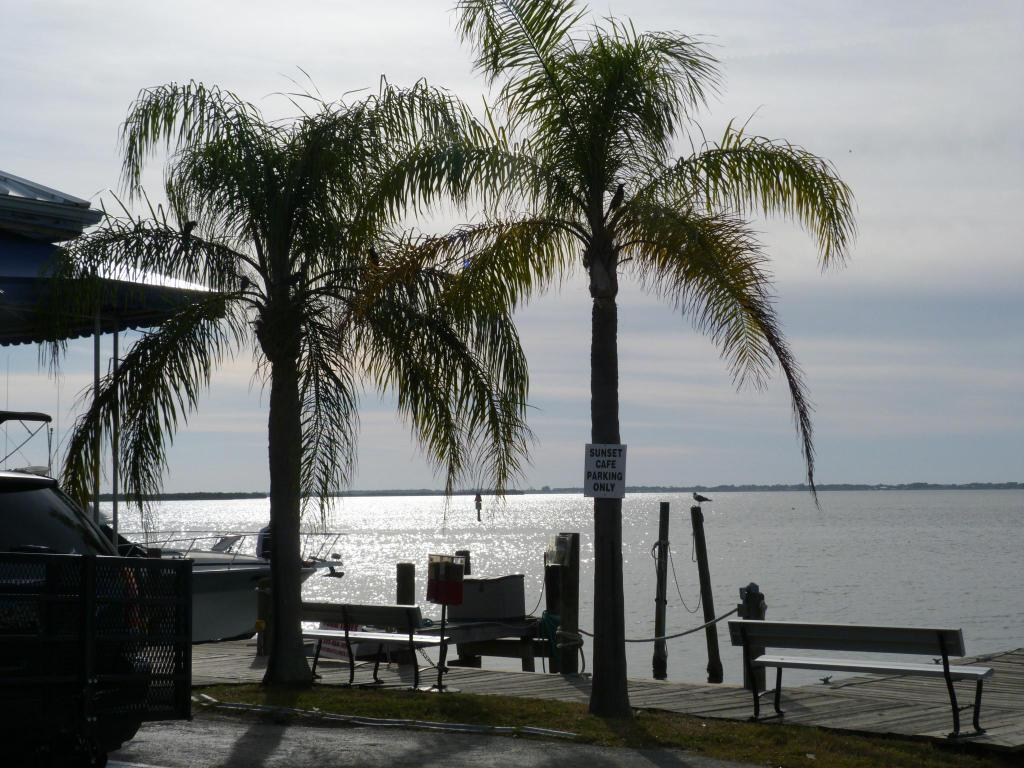What type of vegetation can be seen in the image? There are trees in the image. What is the main object in the water? There is a boat in the water in the image. What type of seating is available in the image? There are benches in the image. What is visible at the top of the image? The sky is visible at the top of the image. What is the primary body of water in the image? The water visible in the image is a river or lake. Can you tell me how many eyes are visible on the boat in the image? There are no eyes visible on the boat in the image. What type of pot is used for cooking on the benches in the image? There is no pot or cooking activity present in the image. 